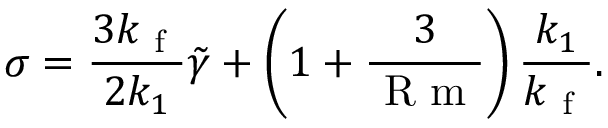<formula> <loc_0><loc_0><loc_500><loc_500>\sigma = \frac { 3 k _ { f } } { 2 k _ { 1 } } \tilde { \gamma } + \left ( 1 + \frac { 3 } { R m } \right ) \frac { k _ { 1 } } { k _ { f } } .</formula> 